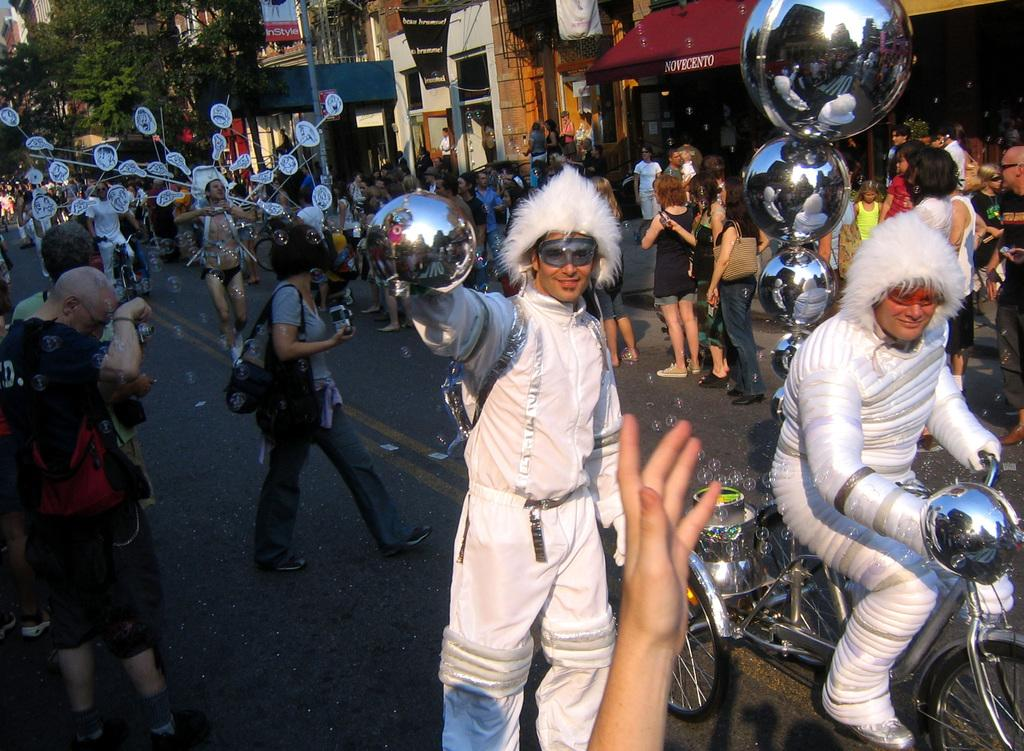What are the people in the image doing? There is a group of people on the ground in the image. What can be seen besides the people? There are bicycles, buildings, and trees in the image. Can you describe the unspecified objects in the image? Unfortunately, the facts provided do not specify the nature of these objects. What type of environment is depicted in the image? The image features a mix of natural elements (trees) and man-made structures (buildings). What type of mask is being worn by the person riding the bicycle in the image? There is no person wearing a mask in the image; the facts provided do not mention any masks. 